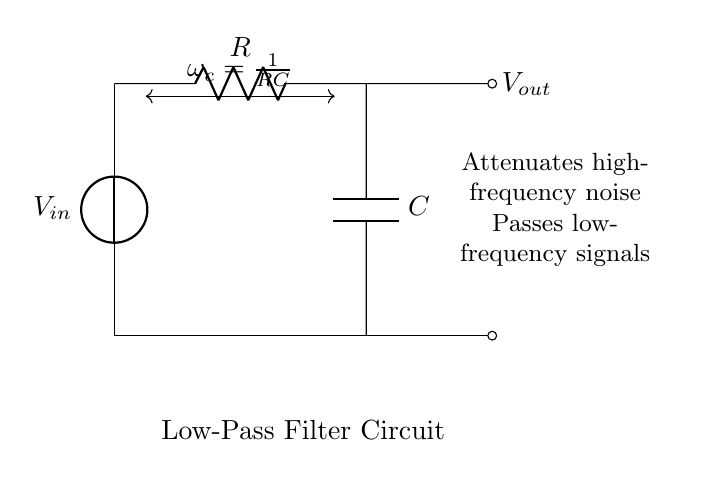What is the input voltage symbol in the circuit? The input voltage in the circuit is represented by the symbol Vin, typically displayed at the left side of the circuit diagram.
Answer: Vin What are the components used in this low-pass filter? The low-pass filter consists of a resistor (R) and a capacitor (C), both shown in the circuit diagram.
Answer: Resistor and Capacitor What is the effect of this low-pass filter on high-frequency signals? This low-pass filter attenuates high-frequency signals, allowing low-frequency signals to pass through instead, as indicated in the description next to the circuit.
Answer: Attenuates What is the formula for the cutoff frequency? The cutoff frequency (omega_c) is given by the formula 1 over (R multiplied by C), which is shown above the resistor and capacitor in the circuit diagram.
Answer: 1/RC What happens to the output voltage in relation to the input voltage? The output voltage (Vout) at the right side of the circuit is influenced by the voltage drop across the resistor and capacitor, reflecting the filtering effect of low-pass filtering on the input voltage.
Answer: Depends on the filter characteristics What type of filter is depicted in the circuit? The circuit diagram represents a low-pass filter, designed to pass low-frequency signals while suppressing higher frequencies, as stated in the lower description.
Answer: Low-pass filter What is the role of the capacitor in this filter circuit? The capacitor in this filter circuit stores and releases energy, primarily allowing low-frequency signals to pass while blocking high-frequency noise, fulfilling its filtering function.
Answer: Energy storage and noise reduction 